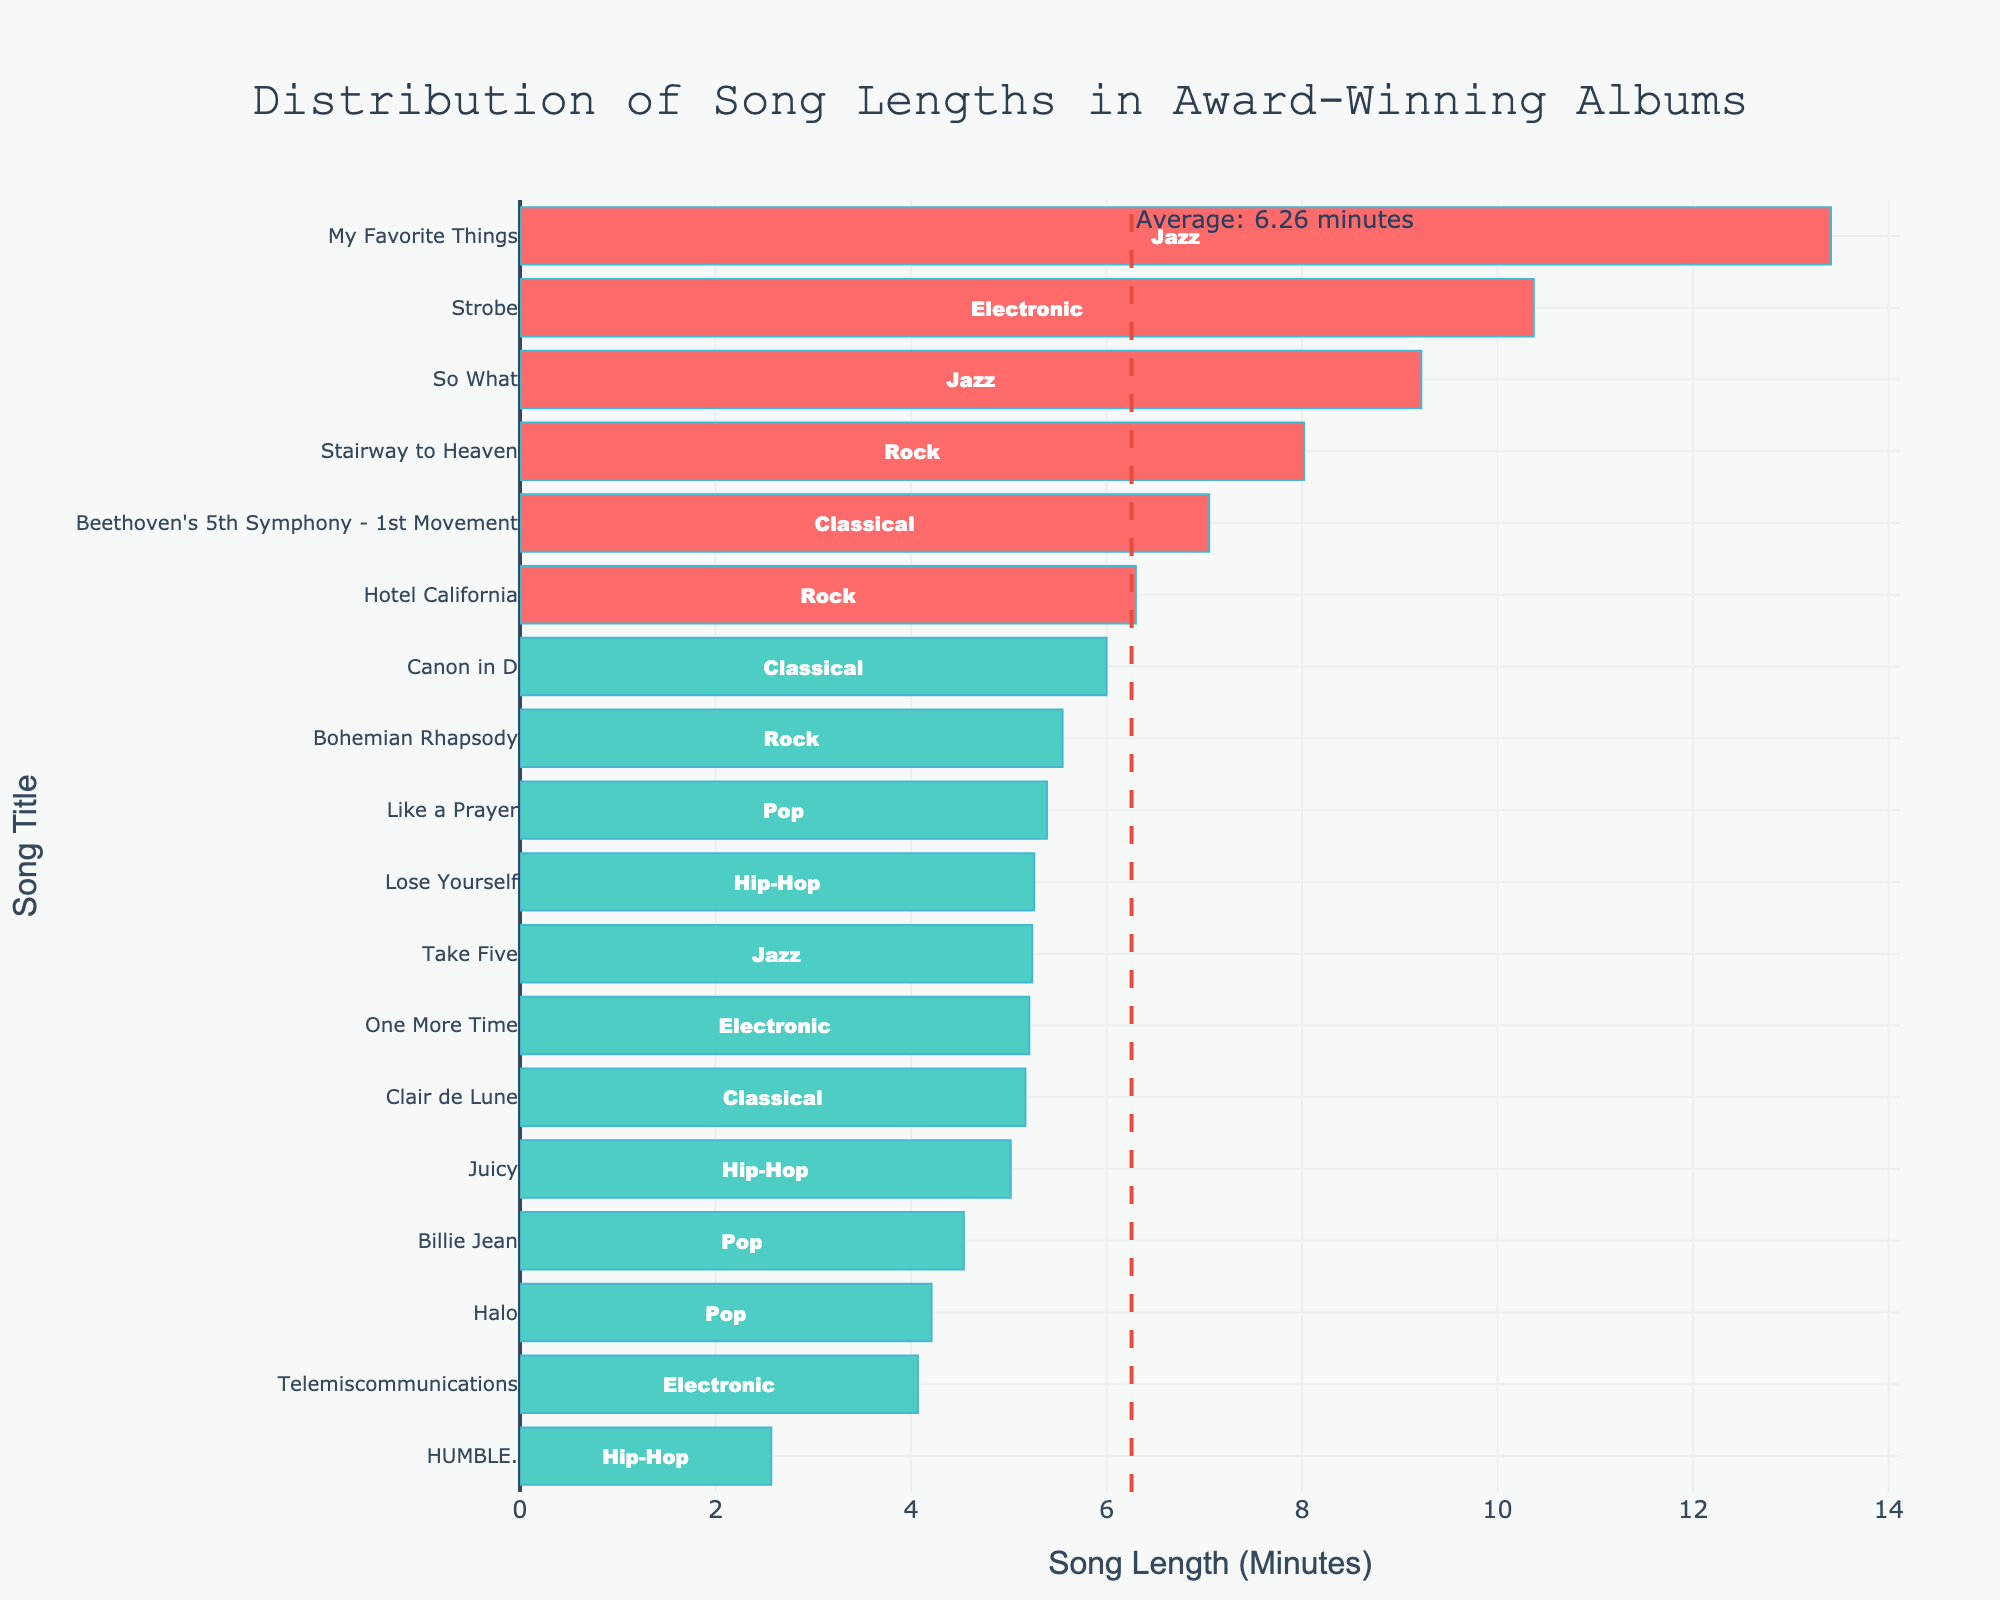What is the average song length in the chart? The plot includes a vertical dashed line labeled "Average: 6.43 minutes," which represents the average song length.
Answer: 6.43 minutes Which song has the longest length and what genre does it belong to? "My Favorite Things" has the longest length, located at the top of the chart with a time of 13.41 minutes. The genre is labeled next to the bar in green color indicating "Jazz."
Answer: My Favorite Things, Jazz How many songs are longer than 8 minutes? By examining the bars that extend beyond the 8-minute mark, we can identify three songs: "Stairway to Heaven," "So What," and "My Favorite Things."
Answer: 3 Which song has the shortest length and what genre does it belong to? "HUMBLE." is listed at the bottom of the chart with a length of 2.57 minutes, and the genre is indicated as "Hip-Hop."
Answer: HUMBLE., Hip-Hop Are there more rock songs above or below the average length? There are two Rock songs ("Stairway to Heaven" and "Hotel California") above the average line and one Rock song ("Bohemian Rhapsody") below it. Therefore, there are more Rock songs above the average length.
Answer: Above How many Pop songs are shorter than the average length? By looking at the Pop songs and comparing their lengths to the average (6.43 minutes), "Billie Jean" and "Halo" are shorter than the average.
Answer: 2 What is the length of "Beethoven's 5th Symphony - 1st Movement" and is it above or below the average line? "Beethoven's 5th Symphony - 1st Movement" has a length of 7.05 minutes, which is above the average line marked at 6.43 minutes.
Answer: 7.05 minutes, above Compare the lengths of "Telemiscommunications" and "One More Time" and determine which is shorter. "Telemiscommunications" (4.07 minutes) is shorter than "One More Time" (5.21 minutes).
Answer: Telemiscommunications Identify the genre with the highest average song length by examining the given data. Jazz has the highest average song lengths with "Take Five" (5.24 minutes), "So What" (9.22 minutes), and "My Favorite Things" (13.41 minutes), indicating a high average in the genre.
Answer: Jazz Which genre has the most songs below the average length? The Pop genre contains three songs, with "Billie Jean" and "Halo" below the average length (6.43 minutes), making it the genre with the most songs below average within its entries.
Answer: Pop 